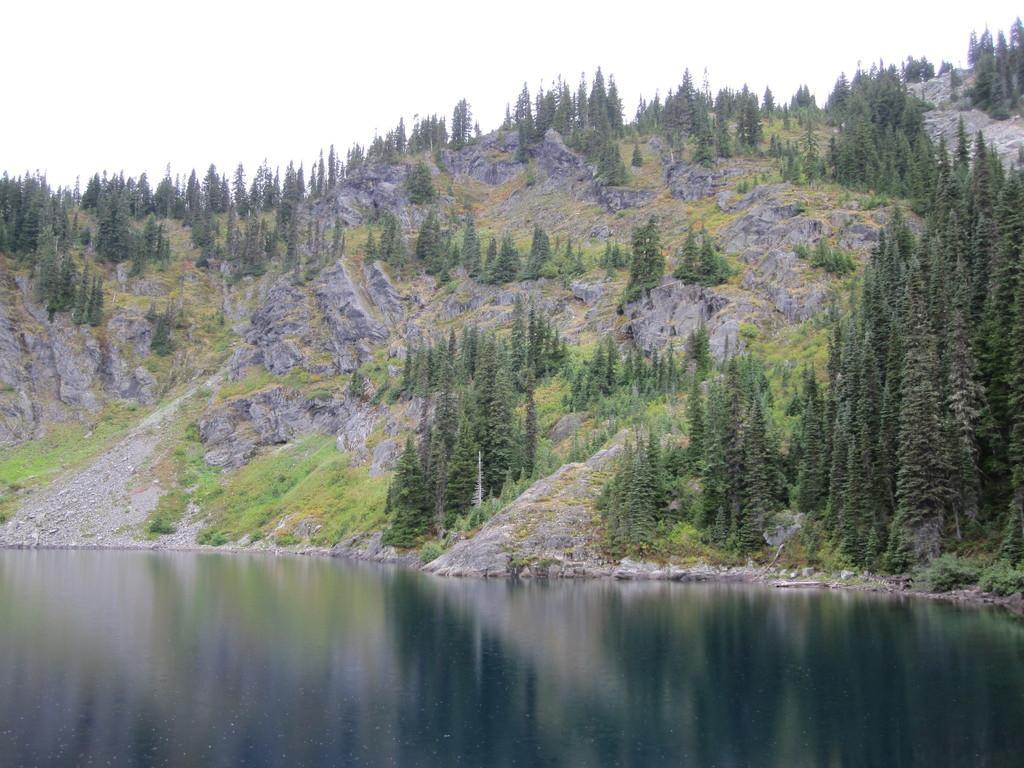Can you describe this image briefly? In this picture there is water at the bottom side of the image and there are trees and mountains in the image. 